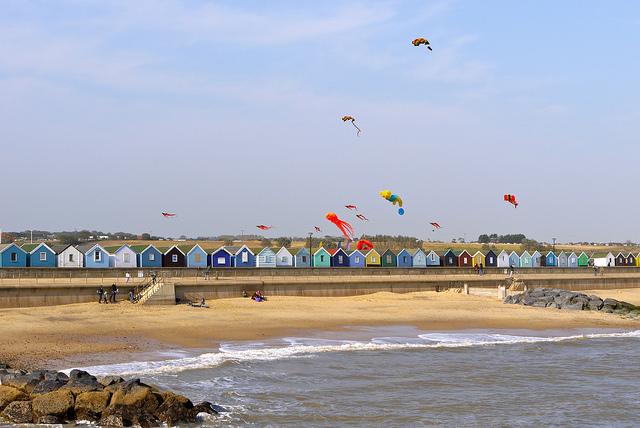What is in the air?
Short answer required. Kites. Can small children participate in this activity?
Answer briefly. Yes. How many kites are there?
Write a very short answer. 12. 